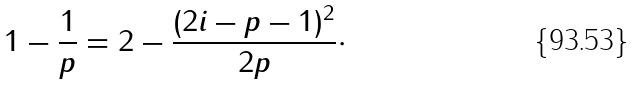<formula> <loc_0><loc_0><loc_500><loc_500>1 - \frac { 1 } { p } = 2 - \frac { ( 2 i - p - 1 ) ^ { 2 } } { 2 p } \cdot</formula> 